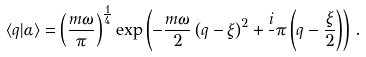<formula> <loc_0><loc_0><loc_500><loc_500>\langle q | \alpha \rangle = \left ( \frac { m \omega } { \pi } \right ) ^ { \frac { 1 } { 4 } } \exp \left ( - \frac { m \omega } { 2 } \left ( q - \xi \right ) ^ { 2 } + \frac { i } { } \pi \left ( q - \frac { \xi } { 2 } \right ) \right ) \, .</formula> 